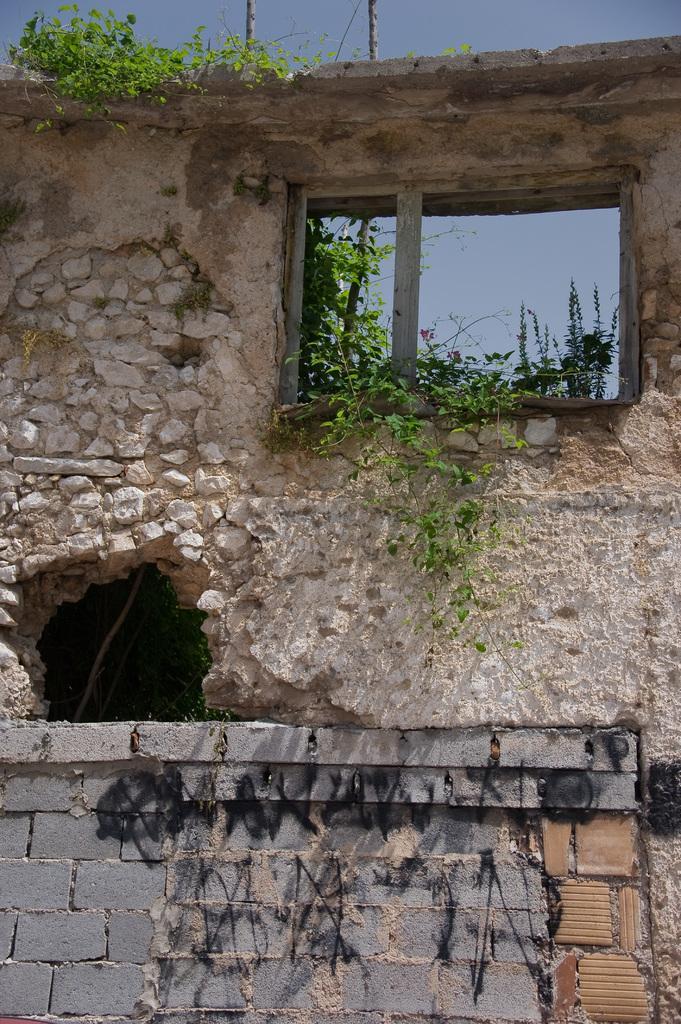Could you give a brief overview of what you see in this image? In this picture we can see a wall in the front, there are plants in the middle, we can see the sky and leaves at the top of the picture. 